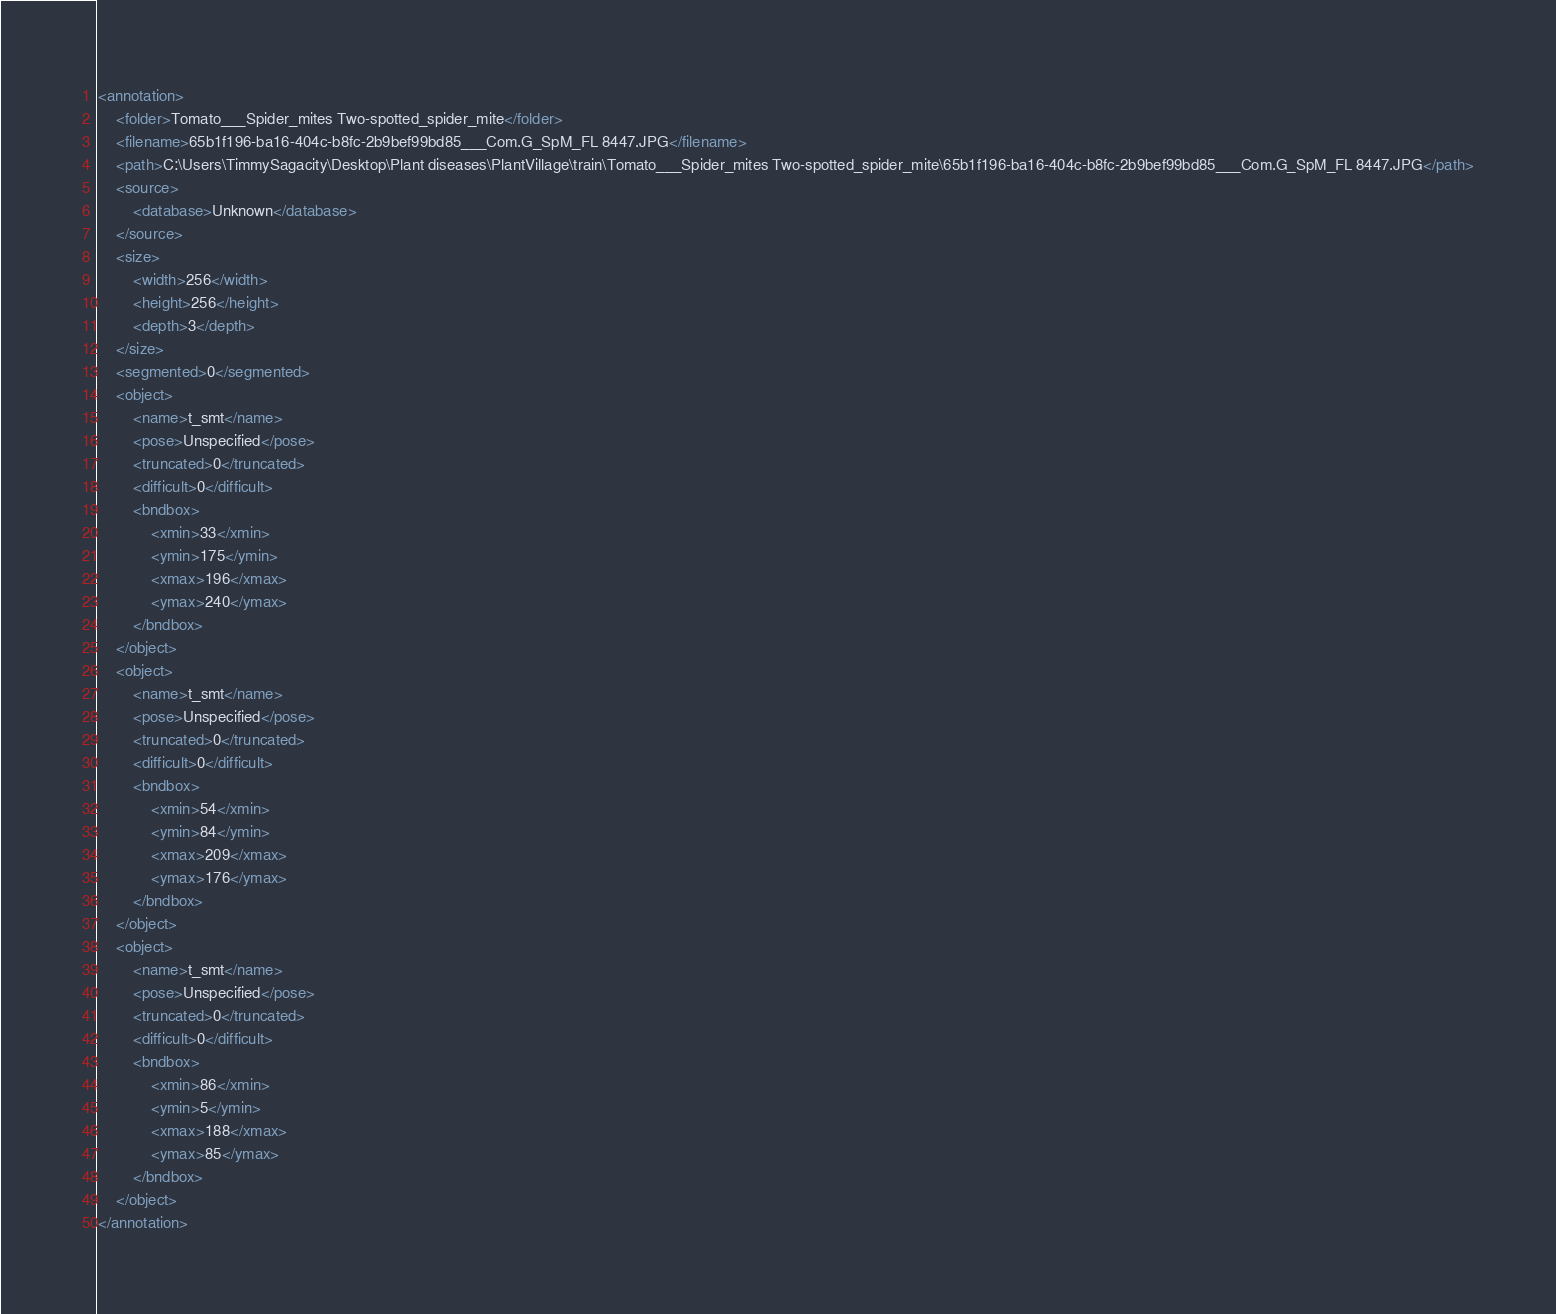Convert code to text. <code><loc_0><loc_0><loc_500><loc_500><_XML_><annotation>
	<folder>Tomato___Spider_mites Two-spotted_spider_mite</folder>
	<filename>65b1f196-ba16-404c-b8fc-2b9bef99bd85___Com.G_SpM_FL 8447.JPG</filename>
	<path>C:\Users\TimmySagacity\Desktop\Plant diseases\PlantVillage\train\Tomato___Spider_mites Two-spotted_spider_mite\65b1f196-ba16-404c-b8fc-2b9bef99bd85___Com.G_SpM_FL 8447.JPG</path>
	<source>
		<database>Unknown</database>
	</source>
	<size>
		<width>256</width>
		<height>256</height>
		<depth>3</depth>
	</size>
	<segmented>0</segmented>
	<object>
		<name>t_smt</name>
		<pose>Unspecified</pose>
		<truncated>0</truncated>
		<difficult>0</difficult>
		<bndbox>
			<xmin>33</xmin>
			<ymin>175</ymin>
			<xmax>196</xmax>
			<ymax>240</ymax>
		</bndbox>
	</object>
	<object>
		<name>t_smt</name>
		<pose>Unspecified</pose>
		<truncated>0</truncated>
		<difficult>0</difficult>
		<bndbox>
			<xmin>54</xmin>
			<ymin>84</ymin>
			<xmax>209</xmax>
			<ymax>176</ymax>
		</bndbox>
	</object>
	<object>
		<name>t_smt</name>
		<pose>Unspecified</pose>
		<truncated>0</truncated>
		<difficult>0</difficult>
		<bndbox>
			<xmin>86</xmin>
			<ymin>5</ymin>
			<xmax>188</xmax>
			<ymax>85</ymax>
		</bndbox>
	</object>
</annotation>
</code> 